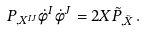Convert formula to latex. <formula><loc_0><loc_0><loc_500><loc_500>P _ { , X ^ { I J } } \dot { \phi } ^ { I } \dot { \phi } ^ { J } = 2 X \tilde { P } _ { , \tilde { X } } \, .</formula> 